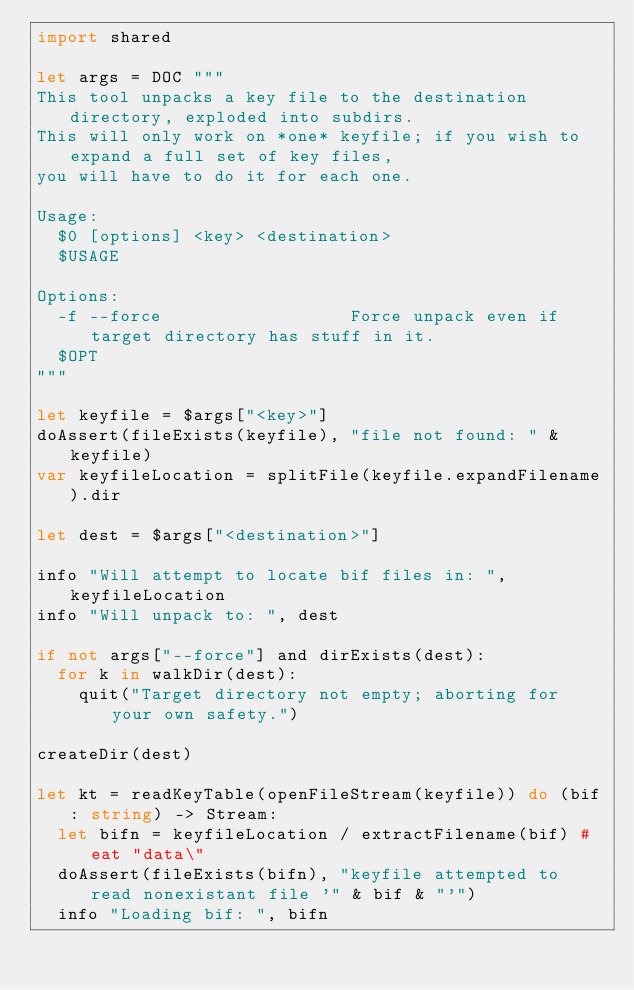<code> <loc_0><loc_0><loc_500><loc_500><_Nim_>import shared

let args = DOC """
This tool unpacks a key file to the destination directory, exploded into subdirs.
This will only work on *one* keyfile; if you wish to expand a full set of key files,
you will have to do it for each one.

Usage:
  $0 [options] <key> <destination>
  $USAGE

Options:
  -f --force                  Force unpack even if target directory has stuff in it.
  $OPT
"""

let keyfile = $args["<key>"]
doAssert(fileExists(keyfile), "file not found: " & keyfile)
var keyfileLocation = splitFile(keyfile.expandFilename).dir

let dest = $args["<destination>"]

info "Will attempt to locate bif files in: ", keyfileLocation
info "Will unpack to: ", dest

if not args["--force"] and dirExists(dest):
  for k in walkDir(dest):
    quit("Target directory not empty; aborting for your own safety.")

createDir(dest)

let kt = readKeyTable(openFileStream(keyfile)) do (bif: string) -> Stream:
  let bifn = keyfileLocation / extractFilename(bif) # eat "data\"
  doAssert(fileExists(bifn), "keyfile attempted to read nonexistant file '" & bif & "'")
  info "Loading bif: ", bifn</code> 